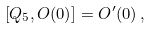<formula> <loc_0><loc_0><loc_500><loc_500>\left [ Q _ { 5 } , O ( 0 ) \right ] = O ^ { \prime } ( 0 ) \, ,</formula> 